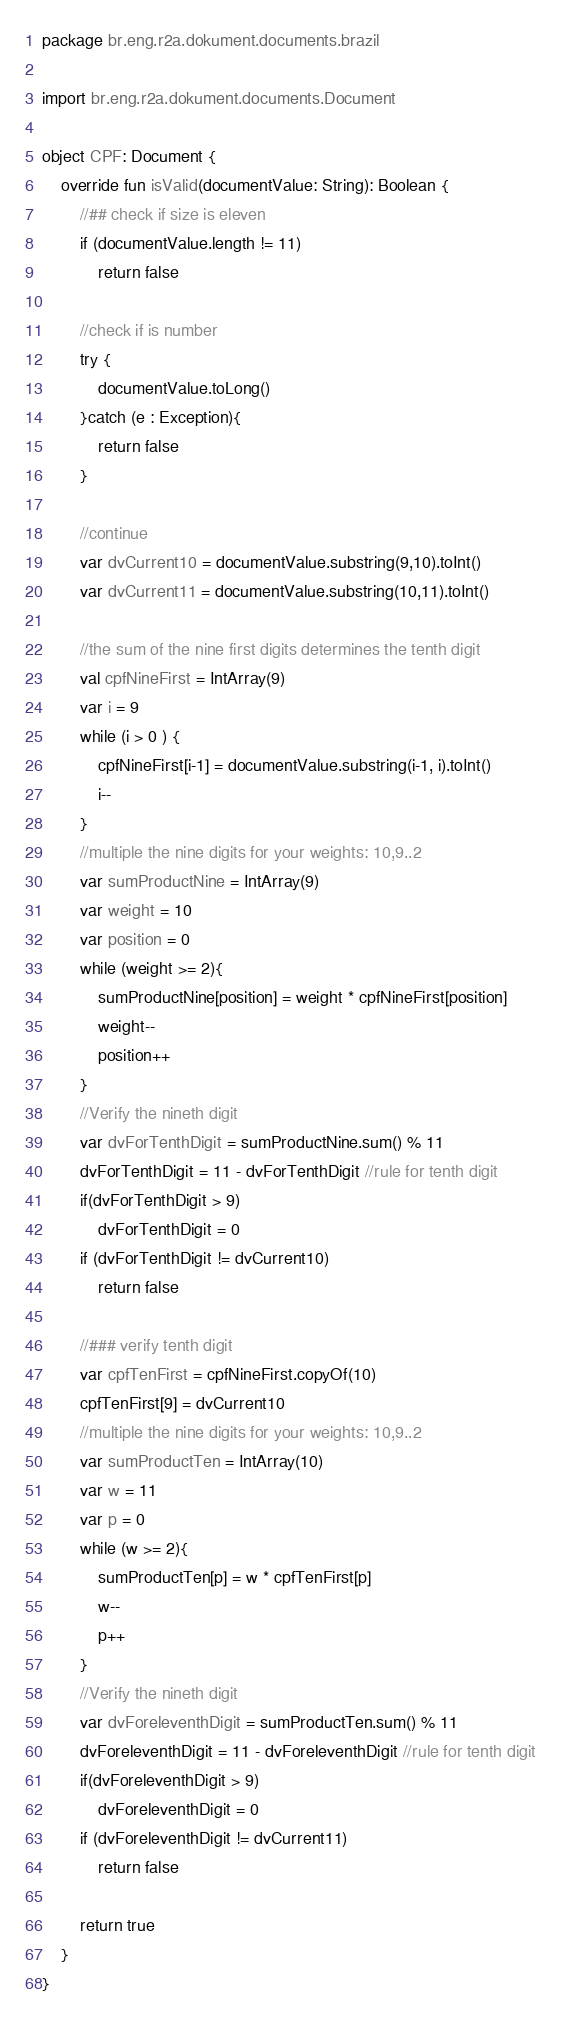Convert code to text. <code><loc_0><loc_0><loc_500><loc_500><_Kotlin_>package br.eng.r2a.dokument.documents.brazil

import br.eng.r2a.dokument.documents.Document

object CPF: Document {
    override fun isValid(documentValue: String): Boolean {
        //## check if size is eleven
        if (documentValue.length != 11)
            return false

        //check if is number
        try {
            documentValue.toLong()
        }catch (e : Exception){
            return false
        }

        //continue
        var dvCurrent10 = documentValue.substring(9,10).toInt()
        var dvCurrent11 = documentValue.substring(10,11).toInt()

        //the sum of the nine first digits determines the tenth digit
        val cpfNineFirst = IntArray(9)
        var i = 9
        while (i > 0 ) {
            cpfNineFirst[i-1] = documentValue.substring(i-1, i).toInt()
            i--
        }
        //multiple the nine digits for your weights: 10,9..2
        var sumProductNine = IntArray(9)
        var weight = 10
        var position = 0
        while (weight >= 2){
            sumProductNine[position] = weight * cpfNineFirst[position]
            weight--
            position++
        }
        //Verify the nineth digit
        var dvForTenthDigit = sumProductNine.sum() % 11
        dvForTenthDigit = 11 - dvForTenthDigit //rule for tenth digit
        if(dvForTenthDigit > 9)
            dvForTenthDigit = 0
        if (dvForTenthDigit != dvCurrent10)
            return false

        //### verify tenth digit
        var cpfTenFirst = cpfNineFirst.copyOf(10)
        cpfTenFirst[9] = dvCurrent10
        //multiple the nine digits for your weights: 10,9..2
        var sumProductTen = IntArray(10)
        var w = 11
        var p = 0
        while (w >= 2){
            sumProductTen[p] = w * cpfTenFirst[p]
            w--
            p++
        }
        //Verify the nineth digit
        var dvForeleventhDigit = sumProductTen.sum() % 11
        dvForeleventhDigit = 11 - dvForeleventhDigit //rule for tenth digit
        if(dvForeleventhDigit > 9)
            dvForeleventhDigit = 0
        if (dvForeleventhDigit != dvCurrent11)
            return false

        return true
    }
}
</code> 